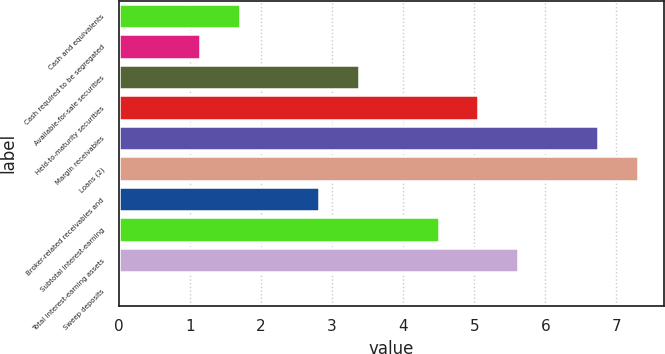Convert chart. <chart><loc_0><loc_0><loc_500><loc_500><bar_chart><fcel>Cash and equivalents<fcel>Cash required to be segregated<fcel>Available-for-sale securities<fcel>Held-to-maturity securities<fcel>Margin receivables<fcel>Loans (2)<fcel>Broker-related receivables and<fcel>Subtotal interest-earning<fcel>Total interest-earning assets<fcel>Sweep deposits<nl><fcel>1.7<fcel>1.14<fcel>3.38<fcel>5.06<fcel>6.74<fcel>7.3<fcel>2.82<fcel>4.5<fcel>5.62<fcel>0.02<nl></chart> 